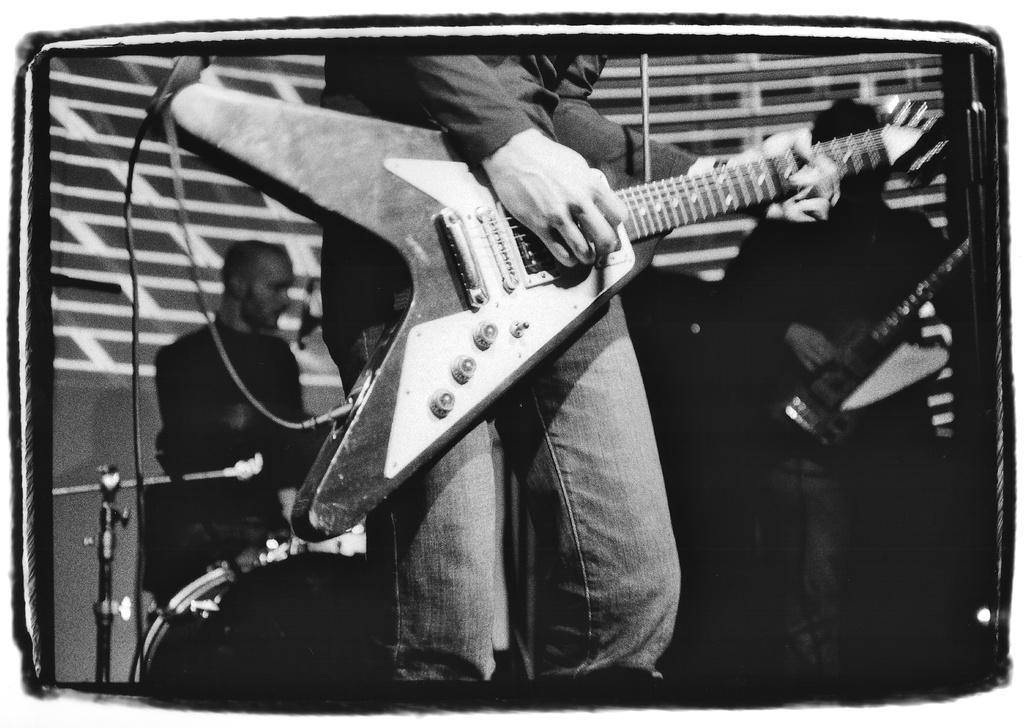How would you summarize this image in a sentence or two? This is a black and white image. Man in front of the picture holding guitar in his hands and playing it. Behind him, we see a man sitting on the chair and on the right corner of the picture, man is holding guitar in his hands. 